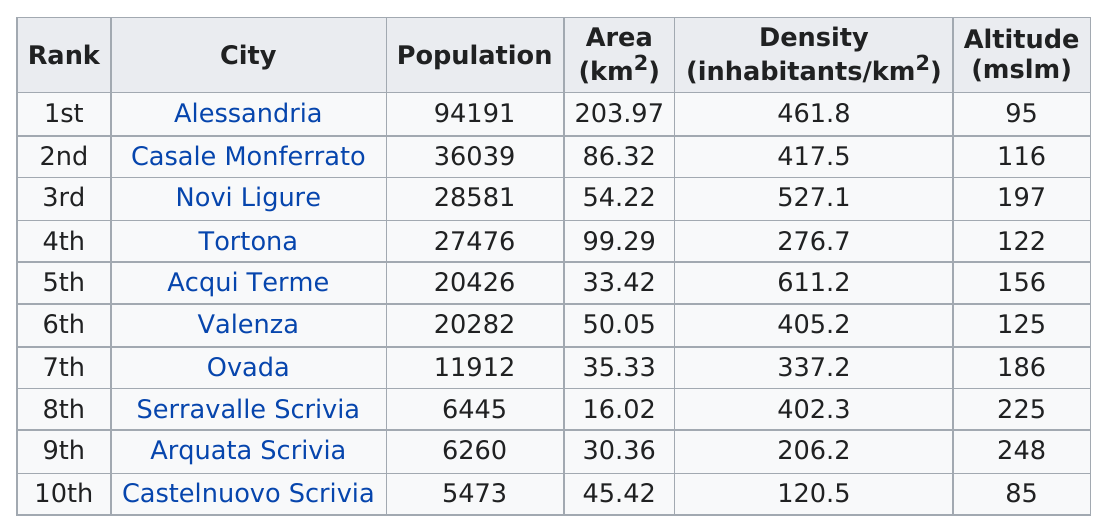Give some essential details in this illustration. Serravalle Scrivia is the city with the smallest area. The average population of the cities in the province of Alessandria is 25,708.5. In Tortona, there are approximately 27,476 people living. Castelnuovo Scrivia is the commune with the least number of inhabitants. The population of Ogada and the population of Serravalle Scrivia are significantly different. The population of Ogada is 5,467, while the population of Serravalle Scrivia is 54,670. 